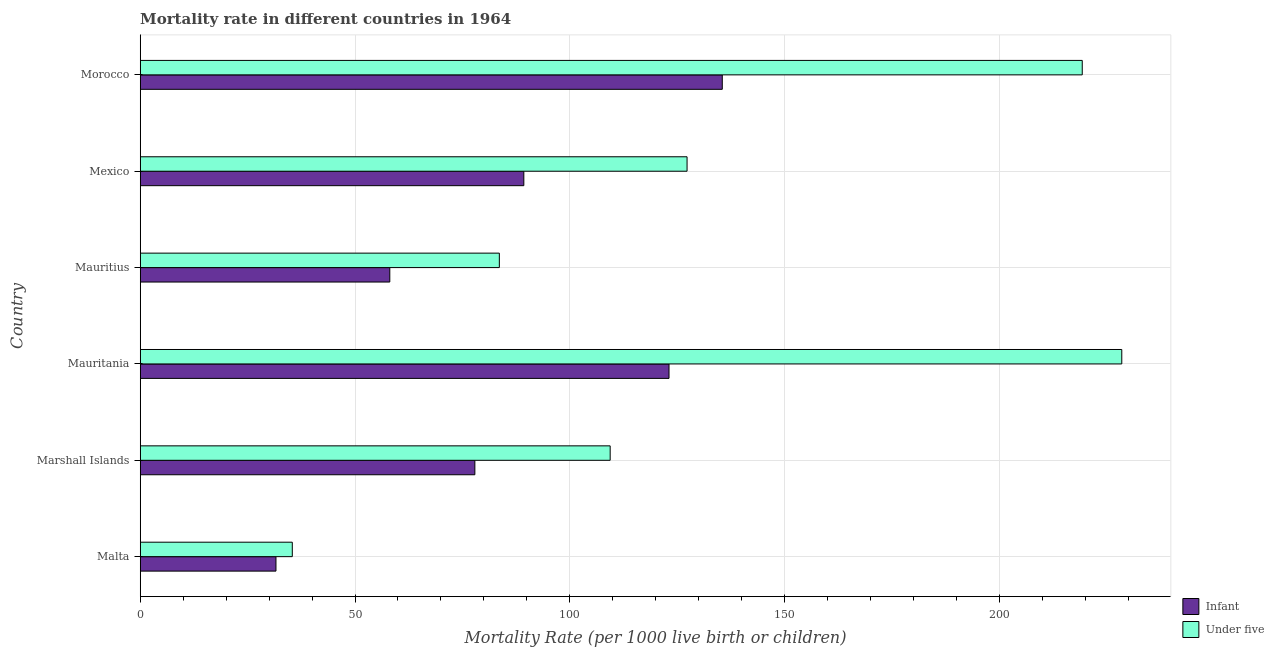How many different coloured bars are there?
Provide a short and direct response. 2. Are the number of bars per tick equal to the number of legend labels?
Keep it short and to the point. Yes. Are the number of bars on each tick of the Y-axis equal?
Provide a succinct answer. Yes. How many bars are there on the 3rd tick from the top?
Ensure brevity in your answer.  2. What is the label of the 3rd group of bars from the top?
Provide a succinct answer. Mauritius. In how many cases, is the number of bars for a given country not equal to the number of legend labels?
Ensure brevity in your answer.  0. What is the infant mortality rate in Mauritius?
Ensure brevity in your answer.  58.1. Across all countries, what is the maximum under-5 mortality rate?
Provide a short and direct response. 228.5. Across all countries, what is the minimum under-5 mortality rate?
Your answer should be very brief. 35.4. In which country was the under-5 mortality rate maximum?
Provide a short and direct response. Mauritania. In which country was the infant mortality rate minimum?
Provide a short and direct response. Malta. What is the total under-5 mortality rate in the graph?
Provide a short and direct response. 803.5. What is the difference between the under-5 mortality rate in Mauritius and that in Morocco?
Provide a short and direct response. -135.7. What is the difference between the under-5 mortality rate in Morocco and the infant mortality rate in Mauritania?
Keep it short and to the point. 96.2. What is the average infant mortality rate per country?
Provide a succinct answer. 85.92. In how many countries, is the infant mortality rate greater than 130 ?
Keep it short and to the point. 1. What is the ratio of the infant mortality rate in Malta to that in Mauritania?
Your response must be concise. 0.26. Is the under-5 mortality rate in Marshall Islands less than that in Morocco?
Provide a succinct answer. Yes. Is the difference between the infant mortality rate in Malta and Marshall Islands greater than the difference between the under-5 mortality rate in Malta and Marshall Islands?
Offer a very short reply. Yes. What is the difference between the highest and the lowest infant mortality rate?
Offer a very short reply. 103.9. Is the sum of the infant mortality rate in Malta and Mauritius greater than the maximum under-5 mortality rate across all countries?
Provide a succinct answer. No. What does the 1st bar from the top in Morocco represents?
Your response must be concise. Under five. What does the 2nd bar from the bottom in Morocco represents?
Offer a terse response. Under five. How many bars are there?
Give a very brief answer. 12. What is the difference between two consecutive major ticks on the X-axis?
Provide a short and direct response. 50. Are the values on the major ticks of X-axis written in scientific E-notation?
Offer a terse response. No. Does the graph contain any zero values?
Provide a succinct answer. No. Does the graph contain grids?
Ensure brevity in your answer.  Yes. How many legend labels are there?
Provide a short and direct response. 2. How are the legend labels stacked?
Offer a terse response. Vertical. What is the title of the graph?
Offer a very short reply. Mortality rate in different countries in 1964. Does "Secondary Education" appear as one of the legend labels in the graph?
Your answer should be very brief. No. What is the label or title of the X-axis?
Your answer should be compact. Mortality Rate (per 1000 live birth or children). What is the label or title of the Y-axis?
Make the answer very short. Country. What is the Mortality Rate (per 1000 live birth or children) in Infant in Malta?
Offer a very short reply. 31.6. What is the Mortality Rate (per 1000 live birth or children) in Under five in Malta?
Offer a very short reply. 35.4. What is the Mortality Rate (per 1000 live birth or children) in Infant in Marshall Islands?
Keep it short and to the point. 77.9. What is the Mortality Rate (per 1000 live birth or children) in Under five in Marshall Islands?
Provide a short and direct response. 109.4. What is the Mortality Rate (per 1000 live birth or children) in Infant in Mauritania?
Your answer should be compact. 123.1. What is the Mortality Rate (per 1000 live birth or children) in Under five in Mauritania?
Provide a short and direct response. 228.5. What is the Mortality Rate (per 1000 live birth or children) of Infant in Mauritius?
Provide a succinct answer. 58.1. What is the Mortality Rate (per 1000 live birth or children) of Under five in Mauritius?
Make the answer very short. 83.6. What is the Mortality Rate (per 1000 live birth or children) of Infant in Mexico?
Offer a very short reply. 89.3. What is the Mortality Rate (per 1000 live birth or children) in Under five in Mexico?
Offer a terse response. 127.3. What is the Mortality Rate (per 1000 live birth or children) of Infant in Morocco?
Your answer should be very brief. 135.5. What is the Mortality Rate (per 1000 live birth or children) in Under five in Morocco?
Provide a short and direct response. 219.3. Across all countries, what is the maximum Mortality Rate (per 1000 live birth or children) of Infant?
Make the answer very short. 135.5. Across all countries, what is the maximum Mortality Rate (per 1000 live birth or children) of Under five?
Offer a very short reply. 228.5. Across all countries, what is the minimum Mortality Rate (per 1000 live birth or children) in Infant?
Make the answer very short. 31.6. Across all countries, what is the minimum Mortality Rate (per 1000 live birth or children) of Under five?
Keep it short and to the point. 35.4. What is the total Mortality Rate (per 1000 live birth or children) in Infant in the graph?
Offer a very short reply. 515.5. What is the total Mortality Rate (per 1000 live birth or children) of Under five in the graph?
Offer a very short reply. 803.5. What is the difference between the Mortality Rate (per 1000 live birth or children) in Infant in Malta and that in Marshall Islands?
Offer a very short reply. -46.3. What is the difference between the Mortality Rate (per 1000 live birth or children) in Under five in Malta and that in Marshall Islands?
Your answer should be compact. -74. What is the difference between the Mortality Rate (per 1000 live birth or children) in Infant in Malta and that in Mauritania?
Give a very brief answer. -91.5. What is the difference between the Mortality Rate (per 1000 live birth or children) of Under five in Malta and that in Mauritania?
Your response must be concise. -193.1. What is the difference between the Mortality Rate (per 1000 live birth or children) in Infant in Malta and that in Mauritius?
Your answer should be very brief. -26.5. What is the difference between the Mortality Rate (per 1000 live birth or children) in Under five in Malta and that in Mauritius?
Offer a terse response. -48.2. What is the difference between the Mortality Rate (per 1000 live birth or children) of Infant in Malta and that in Mexico?
Offer a very short reply. -57.7. What is the difference between the Mortality Rate (per 1000 live birth or children) of Under five in Malta and that in Mexico?
Provide a succinct answer. -91.9. What is the difference between the Mortality Rate (per 1000 live birth or children) in Infant in Malta and that in Morocco?
Your answer should be very brief. -103.9. What is the difference between the Mortality Rate (per 1000 live birth or children) of Under five in Malta and that in Morocco?
Your answer should be compact. -183.9. What is the difference between the Mortality Rate (per 1000 live birth or children) of Infant in Marshall Islands and that in Mauritania?
Offer a terse response. -45.2. What is the difference between the Mortality Rate (per 1000 live birth or children) of Under five in Marshall Islands and that in Mauritania?
Your answer should be compact. -119.1. What is the difference between the Mortality Rate (per 1000 live birth or children) of Infant in Marshall Islands and that in Mauritius?
Provide a short and direct response. 19.8. What is the difference between the Mortality Rate (per 1000 live birth or children) in Under five in Marshall Islands and that in Mauritius?
Your answer should be very brief. 25.8. What is the difference between the Mortality Rate (per 1000 live birth or children) of Infant in Marshall Islands and that in Mexico?
Ensure brevity in your answer.  -11.4. What is the difference between the Mortality Rate (per 1000 live birth or children) in Under five in Marshall Islands and that in Mexico?
Offer a terse response. -17.9. What is the difference between the Mortality Rate (per 1000 live birth or children) of Infant in Marshall Islands and that in Morocco?
Keep it short and to the point. -57.6. What is the difference between the Mortality Rate (per 1000 live birth or children) of Under five in Marshall Islands and that in Morocco?
Provide a succinct answer. -109.9. What is the difference between the Mortality Rate (per 1000 live birth or children) of Infant in Mauritania and that in Mauritius?
Offer a very short reply. 65. What is the difference between the Mortality Rate (per 1000 live birth or children) of Under five in Mauritania and that in Mauritius?
Provide a short and direct response. 144.9. What is the difference between the Mortality Rate (per 1000 live birth or children) in Infant in Mauritania and that in Mexico?
Your response must be concise. 33.8. What is the difference between the Mortality Rate (per 1000 live birth or children) in Under five in Mauritania and that in Mexico?
Provide a short and direct response. 101.2. What is the difference between the Mortality Rate (per 1000 live birth or children) in Infant in Mauritania and that in Morocco?
Keep it short and to the point. -12.4. What is the difference between the Mortality Rate (per 1000 live birth or children) of Infant in Mauritius and that in Mexico?
Give a very brief answer. -31.2. What is the difference between the Mortality Rate (per 1000 live birth or children) in Under five in Mauritius and that in Mexico?
Your response must be concise. -43.7. What is the difference between the Mortality Rate (per 1000 live birth or children) of Infant in Mauritius and that in Morocco?
Provide a short and direct response. -77.4. What is the difference between the Mortality Rate (per 1000 live birth or children) of Under five in Mauritius and that in Morocco?
Offer a terse response. -135.7. What is the difference between the Mortality Rate (per 1000 live birth or children) in Infant in Mexico and that in Morocco?
Your answer should be very brief. -46.2. What is the difference between the Mortality Rate (per 1000 live birth or children) of Under five in Mexico and that in Morocco?
Your response must be concise. -92. What is the difference between the Mortality Rate (per 1000 live birth or children) of Infant in Malta and the Mortality Rate (per 1000 live birth or children) of Under five in Marshall Islands?
Provide a succinct answer. -77.8. What is the difference between the Mortality Rate (per 1000 live birth or children) in Infant in Malta and the Mortality Rate (per 1000 live birth or children) in Under five in Mauritania?
Make the answer very short. -196.9. What is the difference between the Mortality Rate (per 1000 live birth or children) in Infant in Malta and the Mortality Rate (per 1000 live birth or children) in Under five in Mauritius?
Your answer should be very brief. -52. What is the difference between the Mortality Rate (per 1000 live birth or children) in Infant in Malta and the Mortality Rate (per 1000 live birth or children) in Under five in Mexico?
Give a very brief answer. -95.7. What is the difference between the Mortality Rate (per 1000 live birth or children) in Infant in Malta and the Mortality Rate (per 1000 live birth or children) in Under five in Morocco?
Give a very brief answer. -187.7. What is the difference between the Mortality Rate (per 1000 live birth or children) of Infant in Marshall Islands and the Mortality Rate (per 1000 live birth or children) of Under five in Mauritania?
Keep it short and to the point. -150.6. What is the difference between the Mortality Rate (per 1000 live birth or children) in Infant in Marshall Islands and the Mortality Rate (per 1000 live birth or children) in Under five in Mauritius?
Your response must be concise. -5.7. What is the difference between the Mortality Rate (per 1000 live birth or children) in Infant in Marshall Islands and the Mortality Rate (per 1000 live birth or children) in Under five in Mexico?
Your answer should be compact. -49.4. What is the difference between the Mortality Rate (per 1000 live birth or children) of Infant in Marshall Islands and the Mortality Rate (per 1000 live birth or children) of Under five in Morocco?
Your answer should be compact. -141.4. What is the difference between the Mortality Rate (per 1000 live birth or children) in Infant in Mauritania and the Mortality Rate (per 1000 live birth or children) in Under five in Mauritius?
Make the answer very short. 39.5. What is the difference between the Mortality Rate (per 1000 live birth or children) of Infant in Mauritania and the Mortality Rate (per 1000 live birth or children) of Under five in Mexico?
Your answer should be compact. -4.2. What is the difference between the Mortality Rate (per 1000 live birth or children) in Infant in Mauritania and the Mortality Rate (per 1000 live birth or children) in Under five in Morocco?
Your answer should be compact. -96.2. What is the difference between the Mortality Rate (per 1000 live birth or children) in Infant in Mauritius and the Mortality Rate (per 1000 live birth or children) in Under five in Mexico?
Provide a succinct answer. -69.2. What is the difference between the Mortality Rate (per 1000 live birth or children) in Infant in Mauritius and the Mortality Rate (per 1000 live birth or children) in Under five in Morocco?
Give a very brief answer. -161.2. What is the difference between the Mortality Rate (per 1000 live birth or children) in Infant in Mexico and the Mortality Rate (per 1000 live birth or children) in Under five in Morocco?
Keep it short and to the point. -130. What is the average Mortality Rate (per 1000 live birth or children) of Infant per country?
Your answer should be very brief. 85.92. What is the average Mortality Rate (per 1000 live birth or children) of Under five per country?
Your answer should be compact. 133.92. What is the difference between the Mortality Rate (per 1000 live birth or children) of Infant and Mortality Rate (per 1000 live birth or children) of Under five in Malta?
Give a very brief answer. -3.8. What is the difference between the Mortality Rate (per 1000 live birth or children) in Infant and Mortality Rate (per 1000 live birth or children) in Under five in Marshall Islands?
Your answer should be very brief. -31.5. What is the difference between the Mortality Rate (per 1000 live birth or children) of Infant and Mortality Rate (per 1000 live birth or children) of Under five in Mauritania?
Make the answer very short. -105.4. What is the difference between the Mortality Rate (per 1000 live birth or children) in Infant and Mortality Rate (per 1000 live birth or children) in Under five in Mauritius?
Ensure brevity in your answer.  -25.5. What is the difference between the Mortality Rate (per 1000 live birth or children) of Infant and Mortality Rate (per 1000 live birth or children) of Under five in Mexico?
Your answer should be very brief. -38. What is the difference between the Mortality Rate (per 1000 live birth or children) of Infant and Mortality Rate (per 1000 live birth or children) of Under five in Morocco?
Your answer should be very brief. -83.8. What is the ratio of the Mortality Rate (per 1000 live birth or children) of Infant in Malta to that in Marshall Islands?
Keep it short and to the point. 0.41. What is the ratio of the Mortality Rate (per 1000 live birth or children) of Under five in Malta to that in Marshall Islands?
Provide a short and direct response. 0.32. What is the ratio of the Mortality Rate (per 1000 live birth or children) of Infant in Malta to that in Mauritania?
Your answer should be compact. 0.26. What is the ratio of the Mortality Rate (per 1000 live birth or children) of Under five in Malta to that in Mauritania?
Provide a succinct answer. 0.15. What is the ratio of the Mortality Rate (per 1000 live birth or children) of Infant in Malta to that in Mauritius?
Ensure brevity in your answer.  0.54. What is the ratio of the Mortality Rate (per 1000 live birth or children) in Under five in Malta to that in Mauritius?
Make the answer very short. 0.42. What is the ratio of the Mortality Rate (per 1000 live birth or children) of Infant in Malta to that in Mexico?
Your answer should be compact. 0.35. What is the ratio of the Mortality Rate (per 1000 live birth or children) in Under five in Malta to that in Mexico?
Keep it short and to the point. 0.28. What is the ratio of the Mortality Rate (per 1000 live birth or children) in Infant in Malta to that in Morocco?
Offer a terse response. 0.23. What is the ratio of the Mortality Rate (per 1000 live birth or children) of Under five in Malta to that in Morocco?
Offer a very short reply. 0.16. What is the ratio of the Mortality Rate (per 1000 live birth or children) of Infant in Marshall Islands to that in Mauritania?
Your answer should be compact. 0.63. What is the ratio of the Mortality Rate (per 1000 live birth or children) of Under five in Marshall Islands to that in Mauritania?
Provide a short and direct response. 0.48. What is the ratio of the Mortality Rate (per 1000 live birth or children) in Infant in Marshall Islands to that in Mauritius?
Offer a terse response. 1.34. What is the ratio of the Mortality Rate (per 1000 live birth or children) in Under five in Marshall Islands to that in Mauritius?
Your answer should be very brief. 1.31. What is the ratio of the Mortality Rate (per 1000 live birth or children) in Infant in Marshall Islands to that in Mexico?
Provide a short and direct response. 0.87. What is the ratio of the Mortality Rate (per 1000 live birth or children) in Under five in Marshall Islands to that in Mexico?
Make the answer very short. 0.86. What is the ratio of the Mortality Rate (per 1000 live birth or children) in Infant in Marshall Islands to that in Morocco?
Provide a succinct answer. 0.57. What is the ratio of the Mortality Rate (per 1000 live birth or children) in Under five in Marshall Islands to that in Morocco?
Provide a succinct answer. 0.5. What is the ratio of the Mortality Rate (per 1000 live birth or children) of Infant in Mauritania to that in Mauritius?
Offer a terse response. 2.12. What is the ratio of the Mortality Rate (per 1000 live birth or children) in Under five in Mauritania to that in Mauritius?
Provide a short and direct response. 2.73. What is the ratio of the Mortality Rate (per 1000 live birth or children) of Infant in Mauritania to that in Mexico?
Your answer should be very brief. 1.38. What is the ratio of the Mortality Rate (per 1000 live birth or children) of Under five in Mauritania to that in Mexico?
Offer a terse response. 1.79. What is the ratio of the Mortality Rate (per 1000 live birth or children) of Infant in Mauritania to that in Morocco?
Offer a terse response. 0.91. What is the ratio of the Mortality Rate (per 1000 live birth or children) in Under five in Mauritania to that in Morocco?
Your response must be concise. 1.04. What is the ratio of the Mortality Rate (per 1000 live birth or children) of Infant in Mauritius to that in Mexico?
Make the answer very short. 0.65. What is the ratio of the Mortality Rate (per 1000 live birth or children) of Under five in Mauritius to that in Mexico?
Give a very brief answer. 0.66. What is the ratio of the Mortality Rate (per 1000 live birth or children) of Infant in Mauritius to that in Morocco?
Offer a terse response. 0.43. What is the ratio of the Mortality Rate (per 1000 live birth or children) of Under five in Mauritius to that in Morocco?
Your response must be concise. 0.38. What is the ratio of the Mortality Rate (per 1000 live birth or children) of Infant in Mexico to that in Morocco?
Your answer should be compact. 0.66. What is the ratio of the Mortality Rate (per 1000 live birth or children) in Under five in Mexico to that in Morocco?
Your answer should be compact. 0.58. What is the difference between the highest and the second highest Mortality Rate (per 1000 live birth or children) in Infant?
Give a very brief answer. 12.4. What is the difference between the highest and the lowest Mortality Rate (per 1000 live birth or children) in Infant?
Your response must be concise. 103.9. What is the difference between the highest and the lowest Mortality Rate (per 1000 live birth or children) in Under five?
Provide a short and direct response. 193.1. 